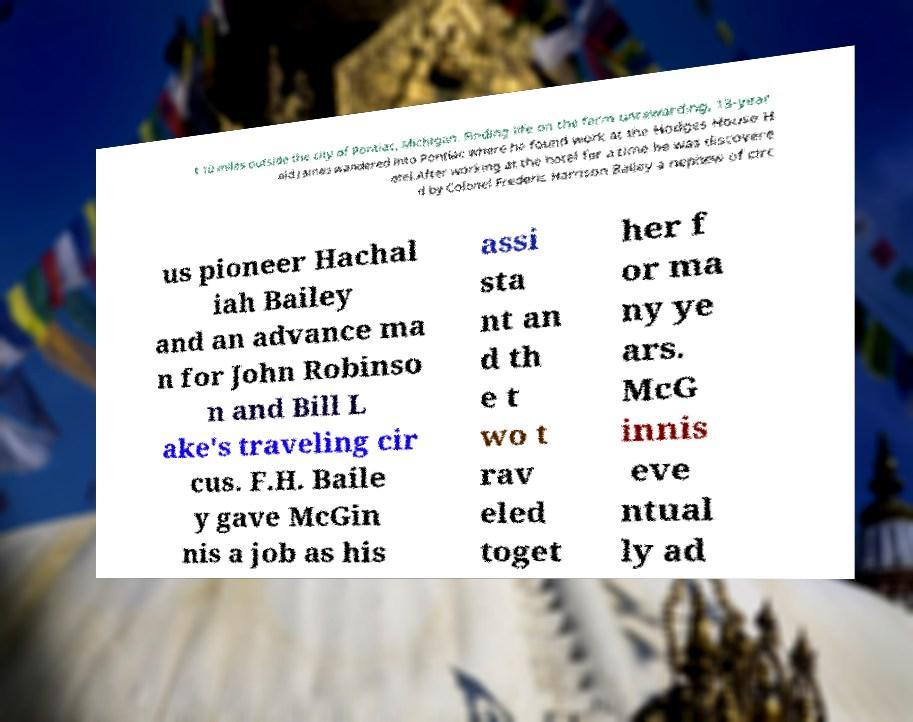Could you assist in decoding the text presented in this image and type it out clearly? t 10 miles outside the city of Pontiac, Michigan. Finding life on the farm unrewarding, 13-year old James wandered into Pontiac where he found work at the Hodges House H otel.After working at the hotel for a time he was discovere d by Colonel Frederic Harrison Bailey a nephew of circ us pioneer Hachal iah Bailey and an advance ma n for John Robinso n and Bill L ake's traveling cir cus. F.H. Baile y gave McGin nis a job as his assi sta nt an d th e t wo t rav eled toget her f or ma ny ye ars. McG innis eve ntual ly ad 